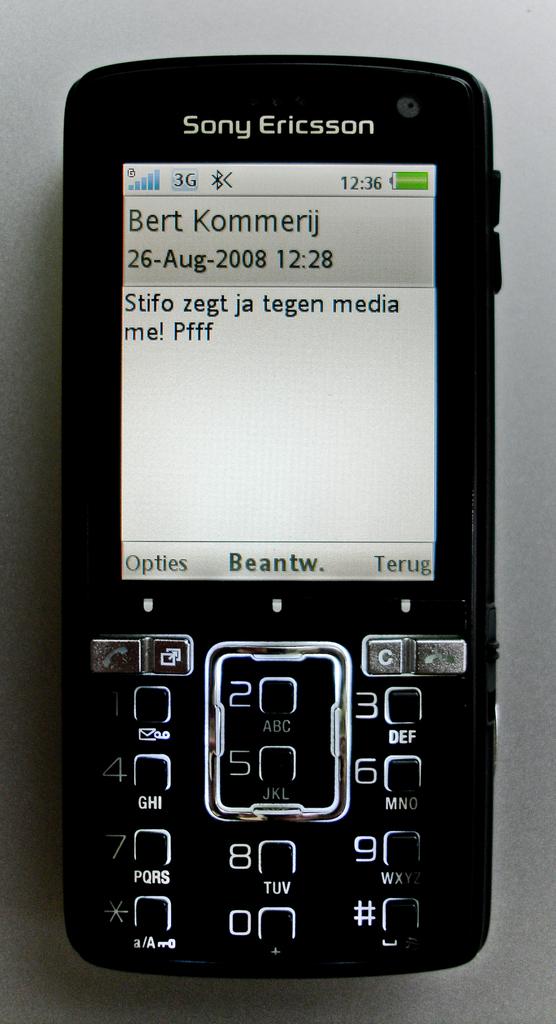What date was the text message sent?
Keep it short and to the point. 26-aug-2008. What brand is the phone?
Provide a short and direct response. Sony ericsson. 